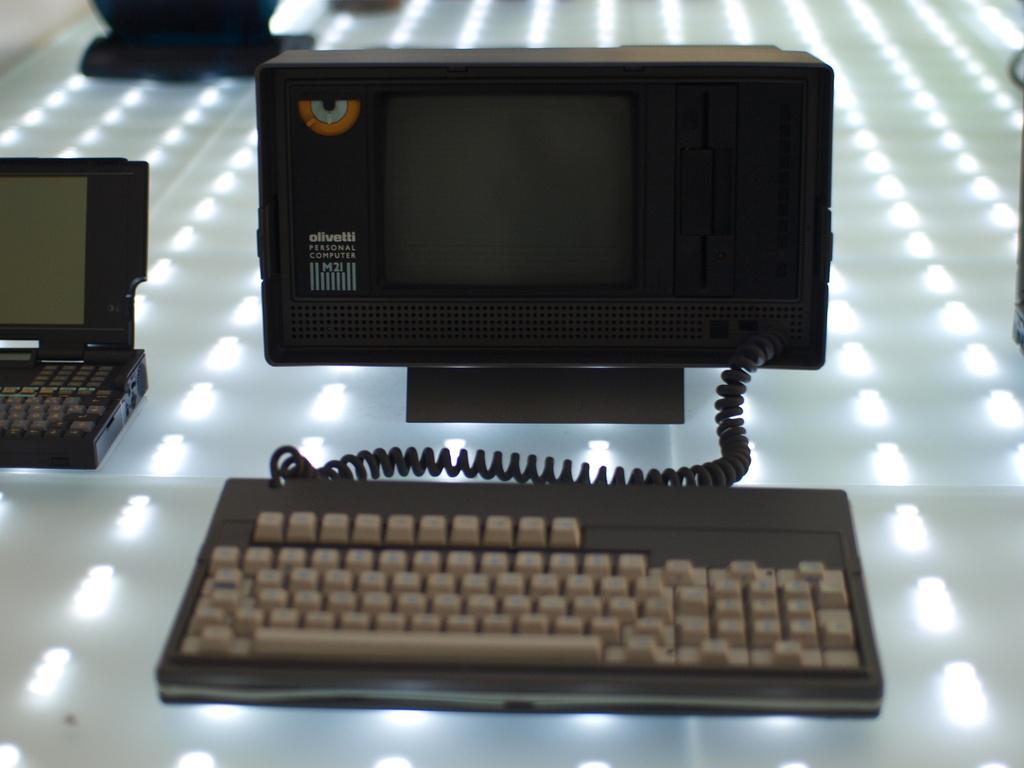What is the brand of this device?
Your answer should be compact. Olivetti. Is this a personal computer?
Your answer should be very brief. Yes. 